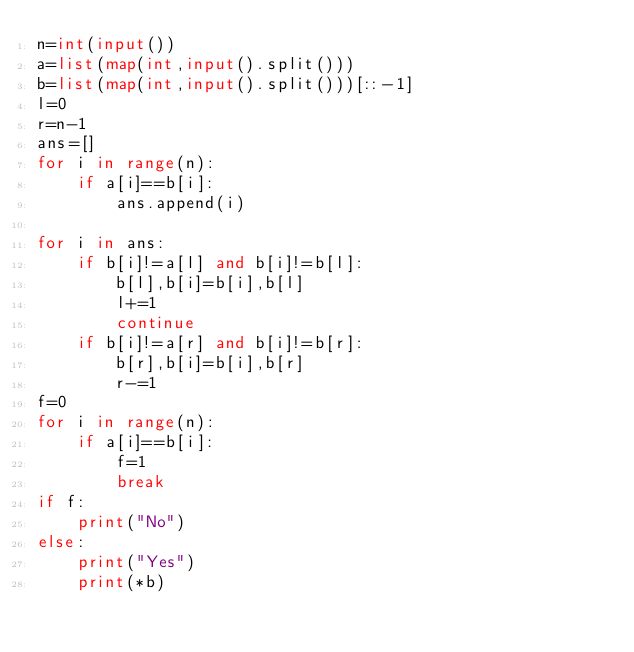Convert code to text. <code><loc_0><loc_0><loc_500><loc_500><_Python_>n=int(input())
a=list(map(int,input().split()))
b=list(map(int,input().split()))[::-1]
l=0
r=n-1
ans=[]
for i in range(n):
    if a[i]==b[i]:
        ans.append(i)

for i in ans:
    if b[i]!=a[l] and b[i]!=b[l]:
        b[l],b[i]=b[i],b[l]
        l+=1
        continue
    if b[i]!=a[r] and b[i]!=b[r]:
        b[r],b[i]=b[i],b[r]
        r-=1
f=0
for i in range(n):
    if a[i]==b[i]:
        f=1
        break
if f:
    print("No")
else:
    print("Yes")
    print(*b)





</code> 